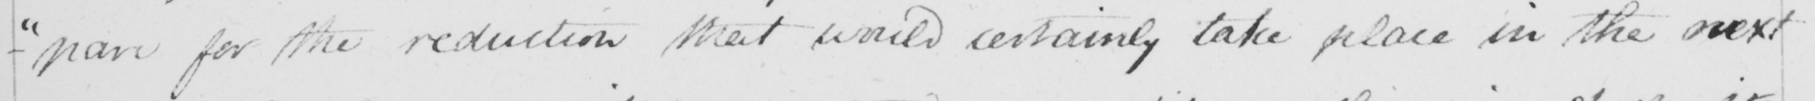Please transcribe the handwritten text in this image. - " pare for the reduction that would certainly take place in the next 